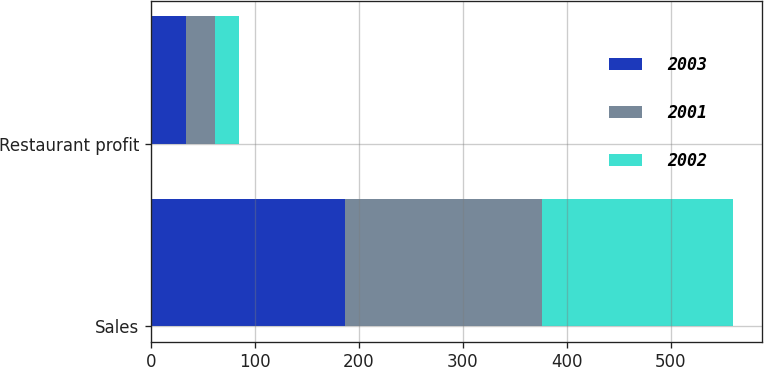Convert chart to OTSL. <chart><loc_0><loc_0><loc_500><loc_500><stacked_bar_chart><ecel><fcel>Sales<fcel>Restaurant profit<nl><fcel>2003<fcel>187<fcel>34<nl><fcel>2001<fcel>189<fcel>28<nl><fcel>2002<fcel>184<fcel>23<nl></chart> 